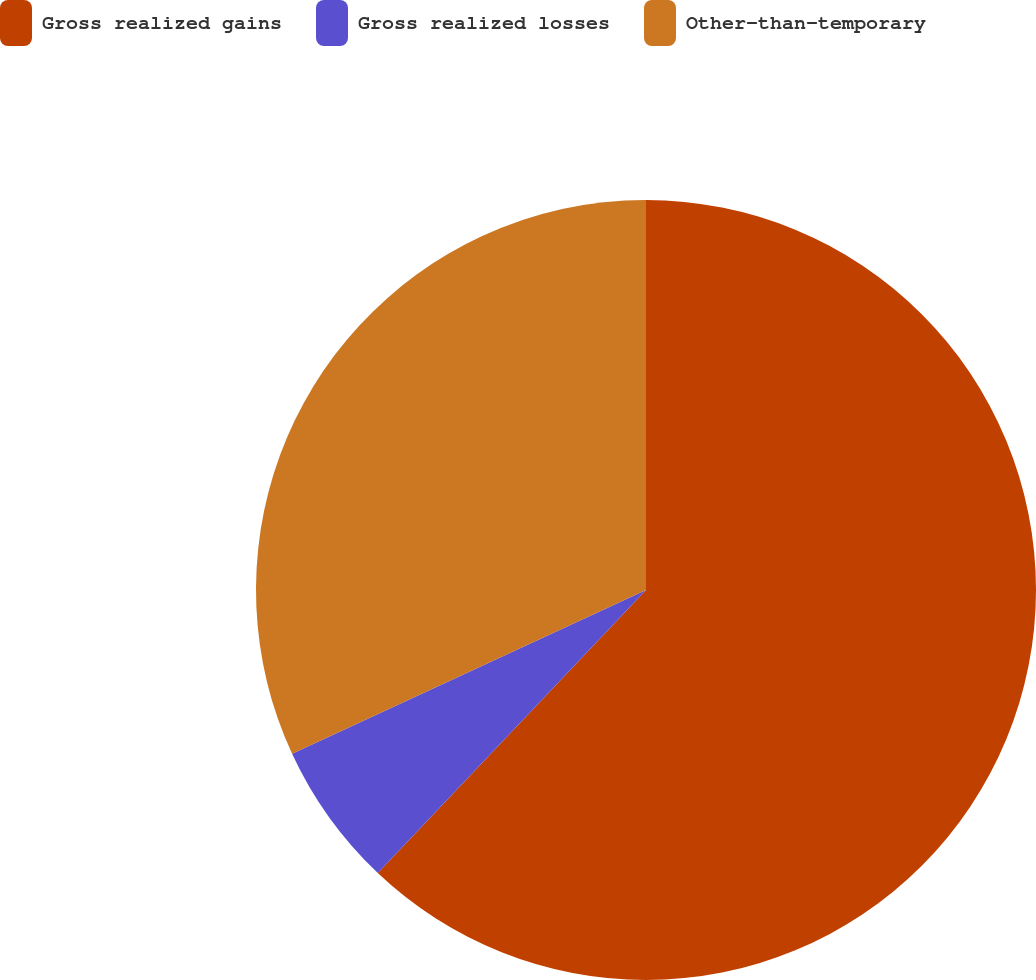<chart> <loc_0><loc_0><loc_500><loc_500><pie_chart><fcel>Gross realized gains<fcel>Gross realized losses<fcel>Other-than-temporary<nl><fcel>62.07%<fcel>6.03%<fcel>31.9%<nl></chart> 